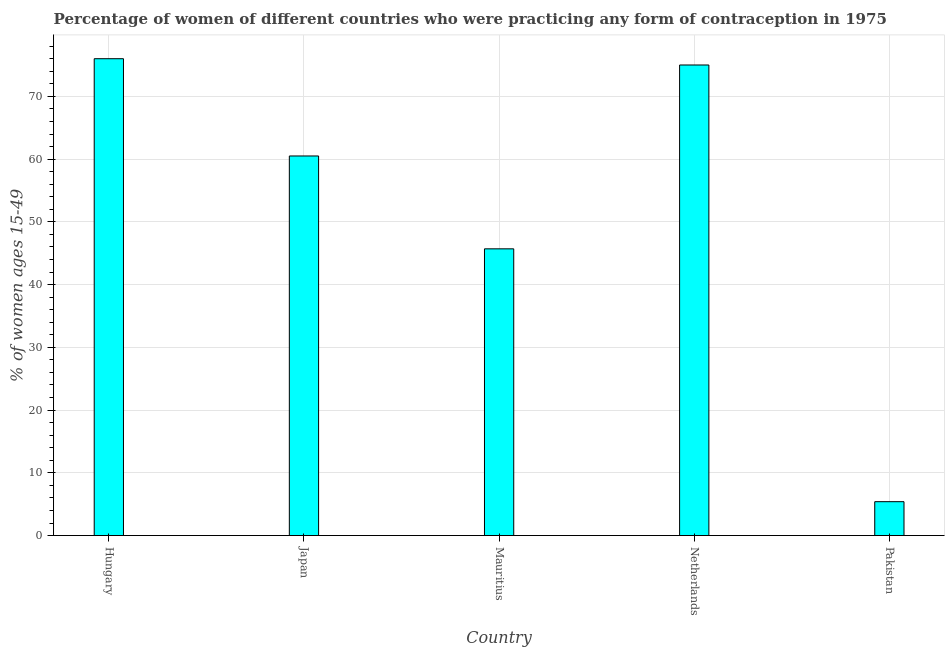Does the graph contain grids?
Ensure brevity in your answer.  Yes. What is the title of the graph?
Offer a very short reply. Percentage of women of different countries who were practicing any form of contraception in 1975. What is the label or title of the Y-axis?
Keep it short and to the point. % of women ages 15-49. What is the contraceptive prevalence in Japan?
Provide a succinct answer. 60.5. In which country was the contraceptive prevalence maximum?
Keep it short and to the point. Hungary. What is the sum of the contraceptive prevalence?
Provide a succinct answer. 262.6. What is the average contraceptive prevalence per country?
Provide a short and direct response. 52.52. What is the median contraceptive prevalence?
Provide a succinct answer. 60.5. What is the ratio of the contraceptive prevalence in Hungary to that in Pakistan?
Offer a terse response. 14.07. Is the contraceptive prevalence in Hungary less than that in Mauritius?
Provide a short and direct response. No. Is the difference between the contraceptive prevalence in Japan and Mauritius greater than the difference between any two countries?
Offer a very short reply. No. Is the sum of the contraceptive prevalence in Hungary and Mauritius greater than the maximum contraceptive prevalence across all countries?
Provide a short and direct response. Yes. What is the difference between the highest and the lowest contraceptive prevalence?
Offer a very short reply. 70.6. How many bars are there?
Make the answer very short. 5. How many countries are there in the graph?
Your response must be concise. 5. What is the % of women ages 15-49 in Hungary?
Make the answer very short. 76. What is the % of women ages 15-49 in Japan?
Ensure brevity in your answer.  60.5. What is the % of women ages 15-49 of Mauritius?
Offer a terse response. 45.7. What is the % of women ages 15-49 in Netherlands?
Your answer should be compact. 75. What is the % of women ages 15-49 in Pakistan?
Your answer should be compact. 5.4. What is the difference between the % of women ages 15-49 in Hungary and Mauritius?
Provide a short and direct response. 30.3. What is the difference between the % of women ages 15-49 in Hungary and Pakistan?
Ensure brevity in your answer.  70.6. What is the difference between the % of women ages 15-49 in Japan and Netherlands?
Make the answer very short. -14.5. What is the difference between the % of women ages 15-49 in Japan and Pakistan?
Provide a succinct answer. 55.1. What is the difference between the % of women ages 15-49 in Mauritius and Netherlands?
Your response must be concise. -29.3. What is the difference between the % of women ages 15-49 in Mauritius and Pakistan?
Keep it short and to the point. 40.3. What is the difference between the % of women ages 15-49 in Netherlands and Pakistan?
Ensure brevity in your answer.  69.6. What is the ratio of the % of women ages 15-49 in Hungary to that in Japan?
Keep it short and to the point. 1.26. What is the ratio of the % of women ages 15-49 in Hungary to that in Mauritius?
Your response must be concise. 1.66. What is the ratio of the % of women ages 15-49 in Hungary to that in Netherlands?
Ensure brevity in your answer.  1.01. What is the ratio of the % of women ages 15-49 in Hungary to that in Pakistan?
Your answer should be very brief. 14.07. What is the ratio of the % of women ages 15-49 in Japan to that in Mauritius?
Your answer should be compact. 1.32. What is the ratio of the % of women ages 15-49 in Japan to that in Netherlands?
Your response must be concise. 0.81. What is the ratio of the % of women ages 15-49 in Japan to that in Pakistan?
Make the answer very short. 11.2. What is the ratio of the % of women ages 15-49 in Mauritius to that in Netherlands?
Provide a short and direct response. 0.61. What is the ratio of the % of women ages 15-49 in Mauritius to that in Pakistan?
Give a very brief answer. 8.46. What is the ratio of the % of women ages 15-49 in Netherlands to that in Pakistan?
Offer a terse response. 13.89. 